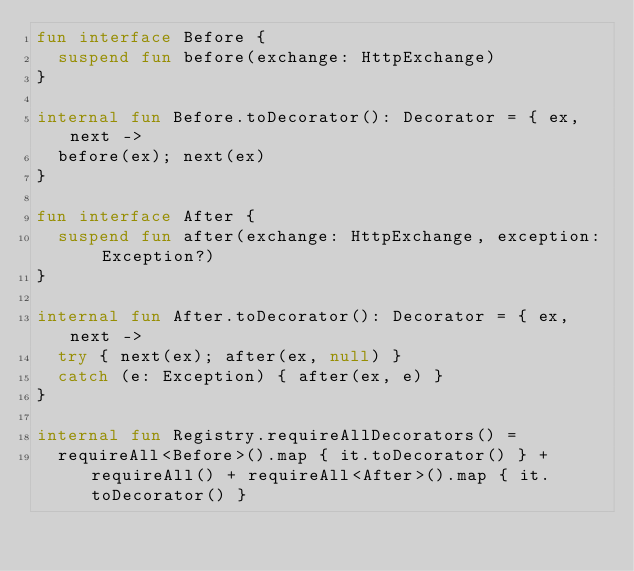Convert code to text. <code><loc_0><loc_0><loc_500><loc_500><_Kotlin_>fun interface Before {
  suspend fun before(exchange: HttpExchange)
}

internal fun Before.toDecorator(): Decorator = { ex, next ->
  before(ex); next(ex)
}

fun interface After {
  suspend fun after(exchange: HttpExchange, exception: Exception?)
}

internal fun After.toDecorator(): Decorator = { ex, next ->
  try { next(ex); after(ex, null) }
  catch (e: Exception) { after(ex, e) }
}

internal fun Registry.requireAllDecorators() =
  requireAll<Before>().map { it.toDecorator() } + requireAll() + requireAll<After>().map { it.toDecorator() }
</code> 